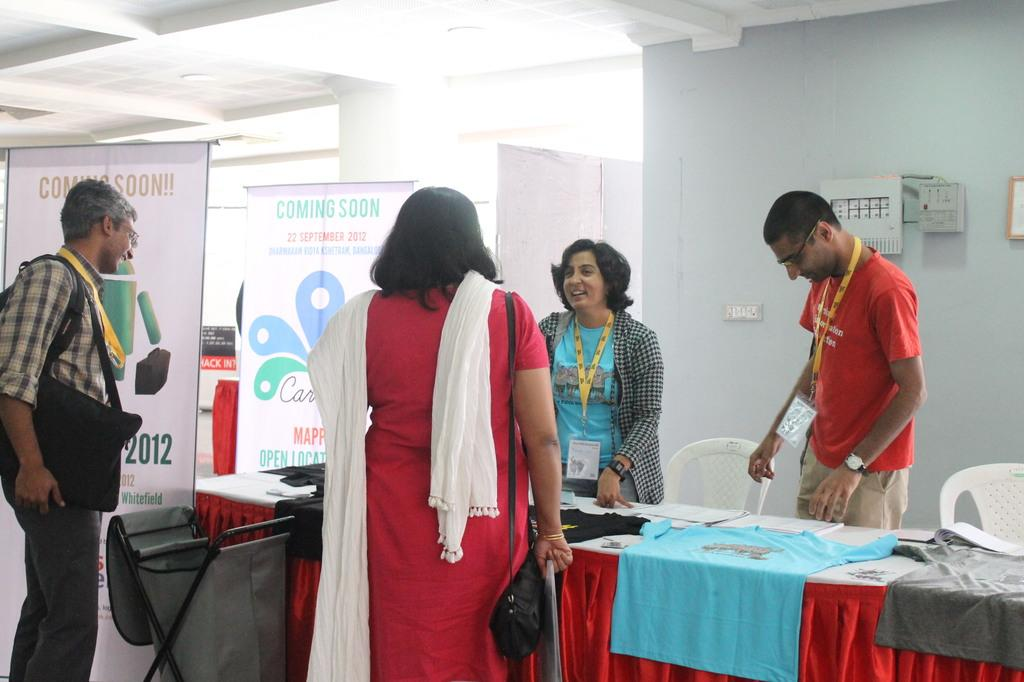What is happening in the image? There are people standing in the image. What are two of the people wearing? Two of the people are wearing bags. What can be seen in the background of the image? There are chairs, a wall, and banners in the background of the image. Can you describe the zephyr that is blowing the goat's knee in the image? There is no zephyr, goat, or knee present in the image. 